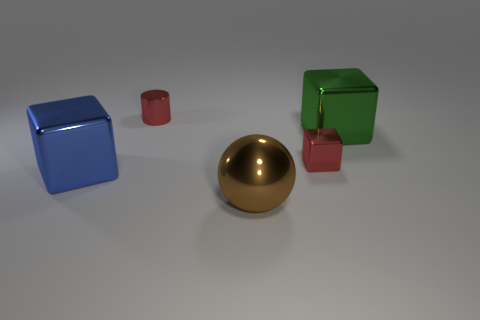Add 1 small gray matte cylinders. How many objects exist? 6 Subtract all cubes. How many objects are left? 2 Add 1 big spheres. How many big spheres are left? 2 Add 1 shiny objects. How many shiny objects exist? 6 Subtract 0 green cylinders. How many objects are left? 5 Subtract all big cubes. Subtract all small cubes. How many objects are left? 2 